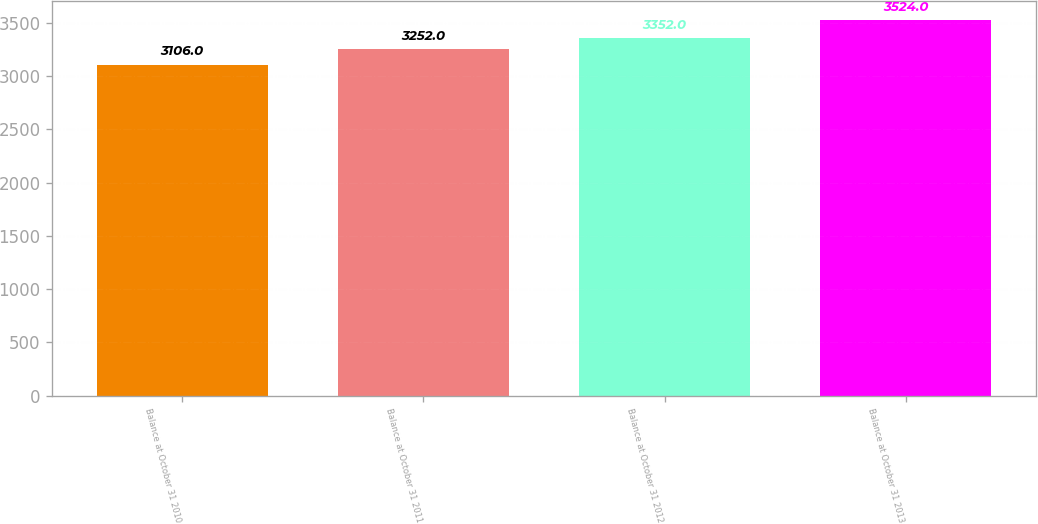<chart> <loc_0><loc_0><loc_500><loc_500><bar_chart><fcel>Balance at October 31 2010<fcel>Balance at October 31 2011<fcel>Balance at October 31 2012<fcel>Balance at October 31 2013<nl><fcel>3106<fcel>3252<fcel>3352<fcel>3524<nl></chart> 